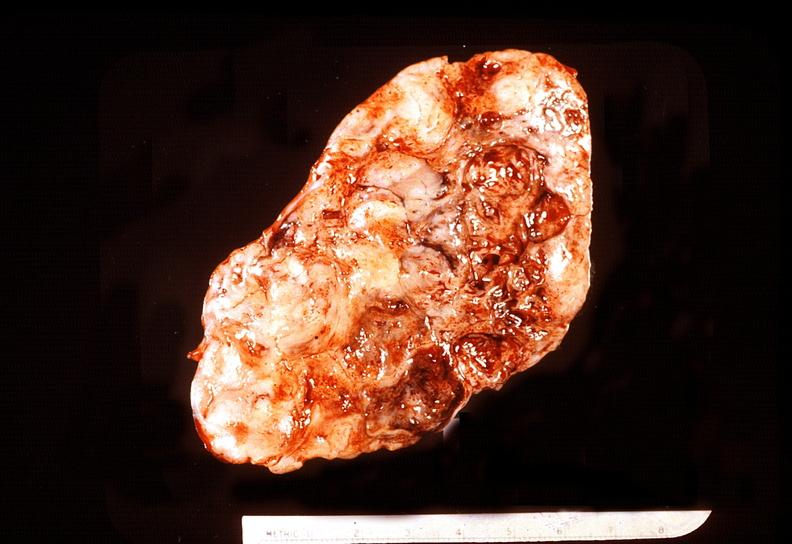what is present?
Answer the question using a single word or phrase. Endocrine 